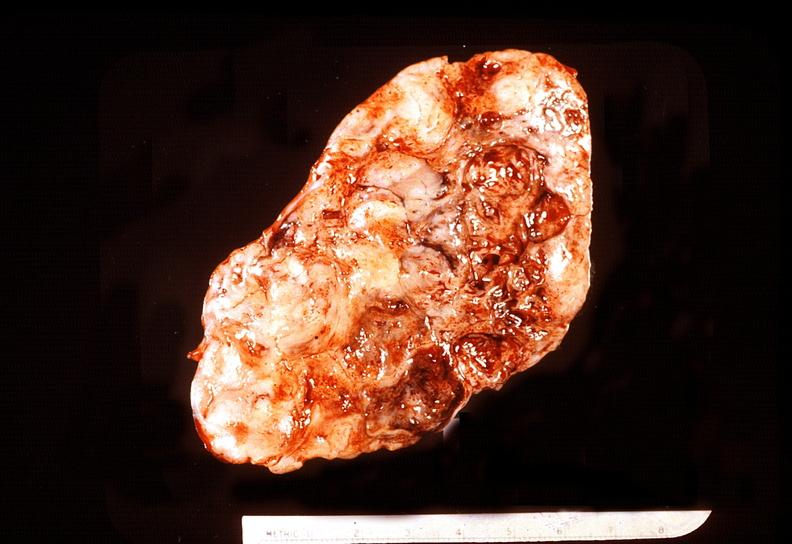what is present?
Answer the question using a single word or phrase. Endocrine 